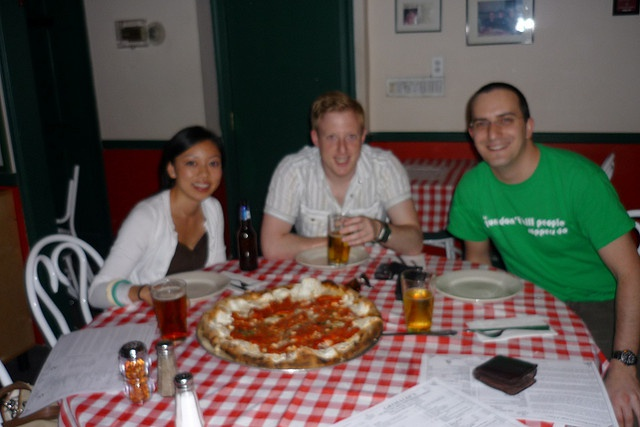Describe the objects in this image and their specific colors. I can see dining table in black, darkgray, brown, gray, and maroon tones, people in black, darkgreen, and brown tones, people in black, darkgray, and gray tones, people in black, darkgray, and brown tones, and pizza in black, maroon, brown, and gray tones in this image. 